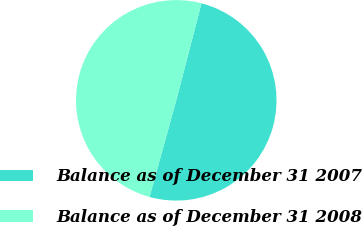<chart> <loc_0><loc_0><loc_500><loc_500><pie_chart><fcel>Balance as of December 31 2007<fcel>Balance as of December 31 2008<nl><fcel>50.25%<fcel>49.75%<nl></chart> 